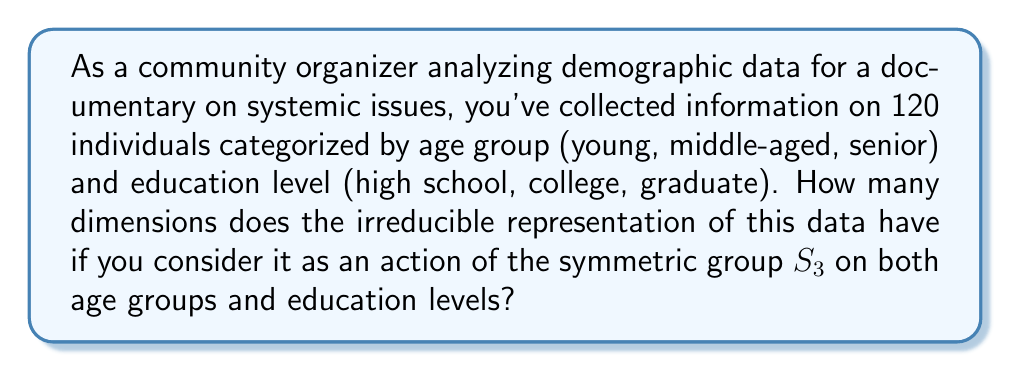Show me your answer to this math problem. To solve this problem, we'll follow these steps:

1) First, we need to understand that we're dealing with two sets of three categories each (age groups and education levels). This suggests we're working with the symmetric group $S_3 \times S_3$.

2) The irreducible representations of a direct product of groups are tensor products of irreducible representations of the individual groups. So, we need to find the irreducible representations of $S_3$ and then consider their tensor products.

3) $S_3$ has three irreducible representations:
   - The trivial representation, dimension 1
   - The sign representation, dimension 1
   - The standard representation, dimension 2

4) Let's denote these as $\rho_1$ (trivial), $\rho_2$ (sign), and $\rho_3$ (standard).

5) The irreducible representations of $S_3 \times S_3$ are then:
   $\rho_1 \otimes \rho_1$, $\rho_1 \otimes \rho_2$, $\rho_1 \otimes \rho_3$
   $\rho_2 \otimes \rho_1$, $\rho_2 \otimes \rho_2$, $\rho_2 \otimes \rho_3$
   $\rho_3 \otimes \rho_1$, $\rho_3 \otimes \rho_2$, $\rho_3 \otimes \rho_3$

6) The dimensions of these tensor products are:
   $1 \times 1 = 1$, $1 \times 1 = 1$, $1 \times 2 = 2$
   $1 \times 1 = 1$, $1 \times 1 = 1$, $1 \times 2 = 2$
   $2 \times 1 = 2$, $2 \times 1 = 2$, $2 \times 2 = 4$

7) Therefore, the dimensions of the irreducible representations of $S_3 \times S_3$ are 1, 1, 2, 1, 1, 2, 2, 2, and 4.

8) The largest dimension among these is 4.
Answer: 4 